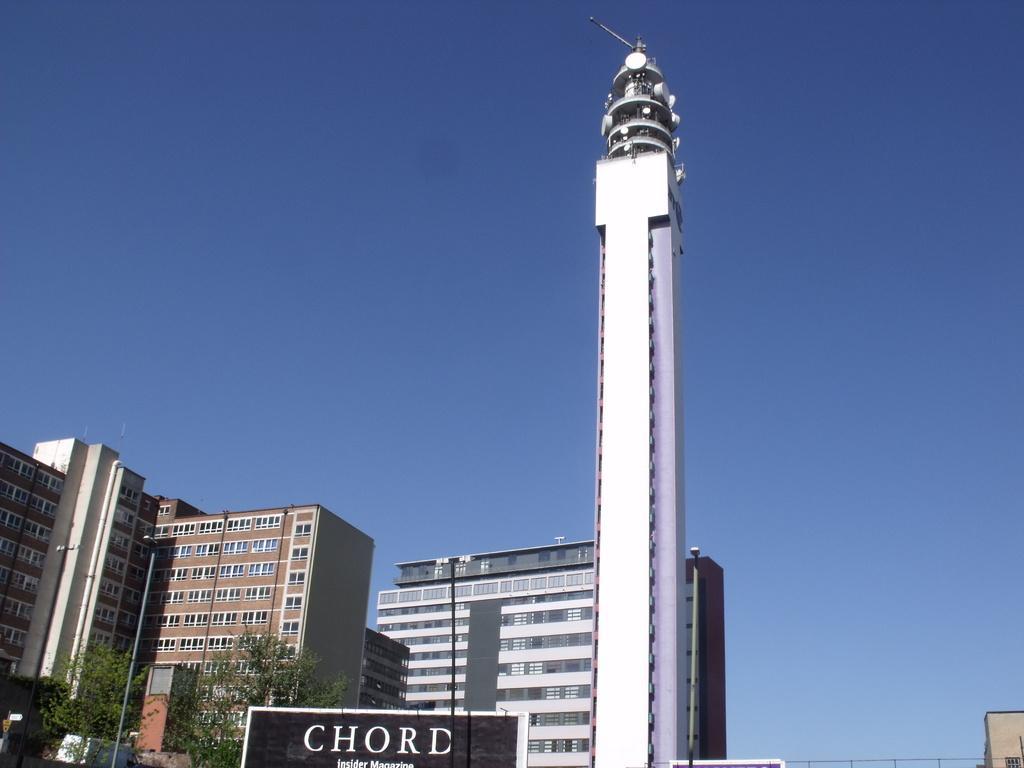Can you describe this image briefly? In this image, we can see a tower, buildings, walls and windows. At the bottom, there are few trees, poles and hoarding. Background there is a clear sky. 